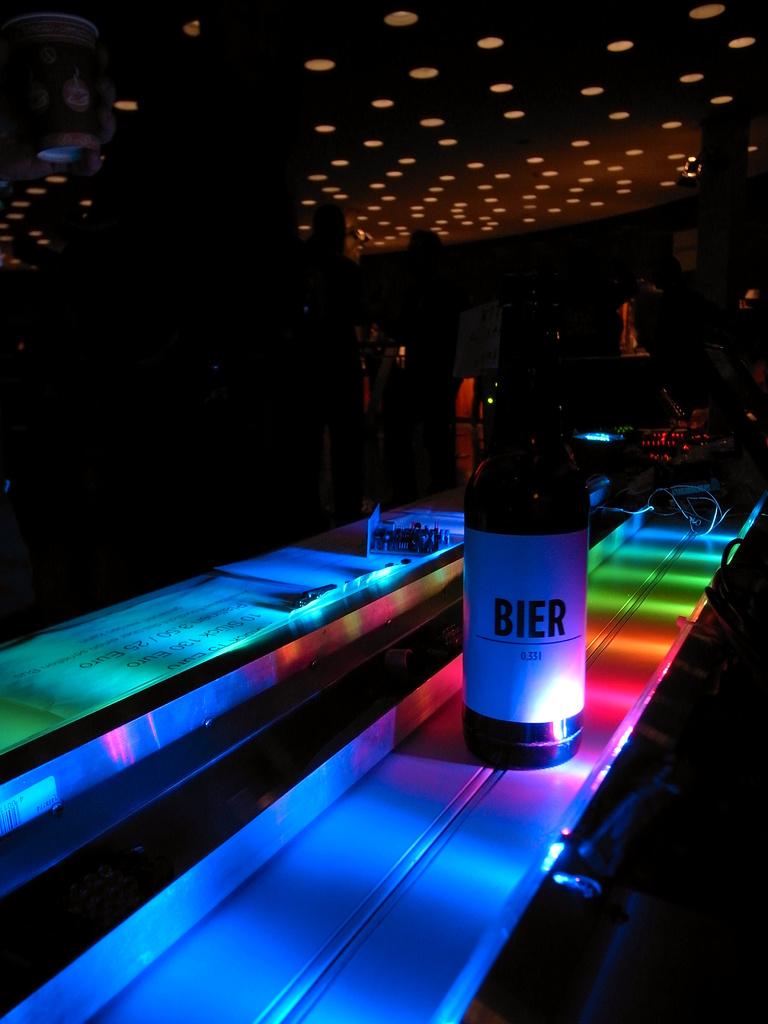What brand of beer?
Keep it short and to the point. Bier. 